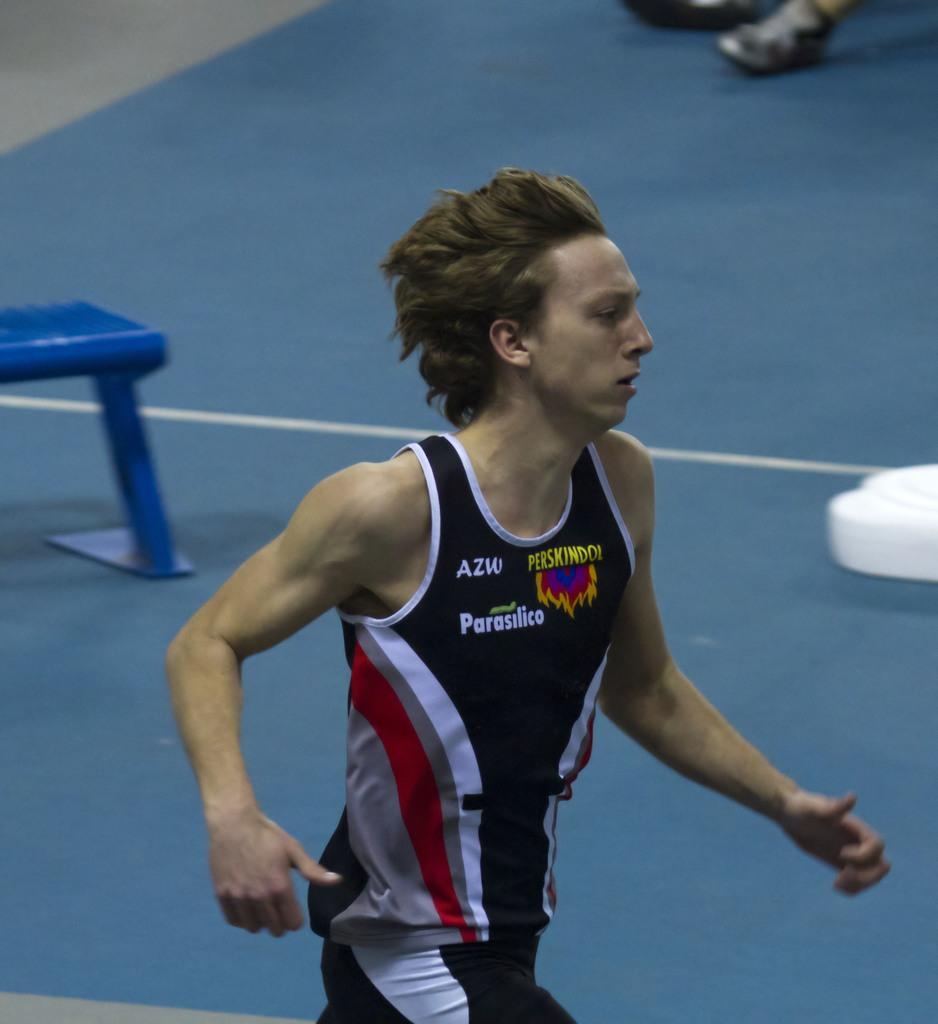<image>
Render a clear and concise summary of the photo. A man wears a shirt with "AZW" on the upper right side. 